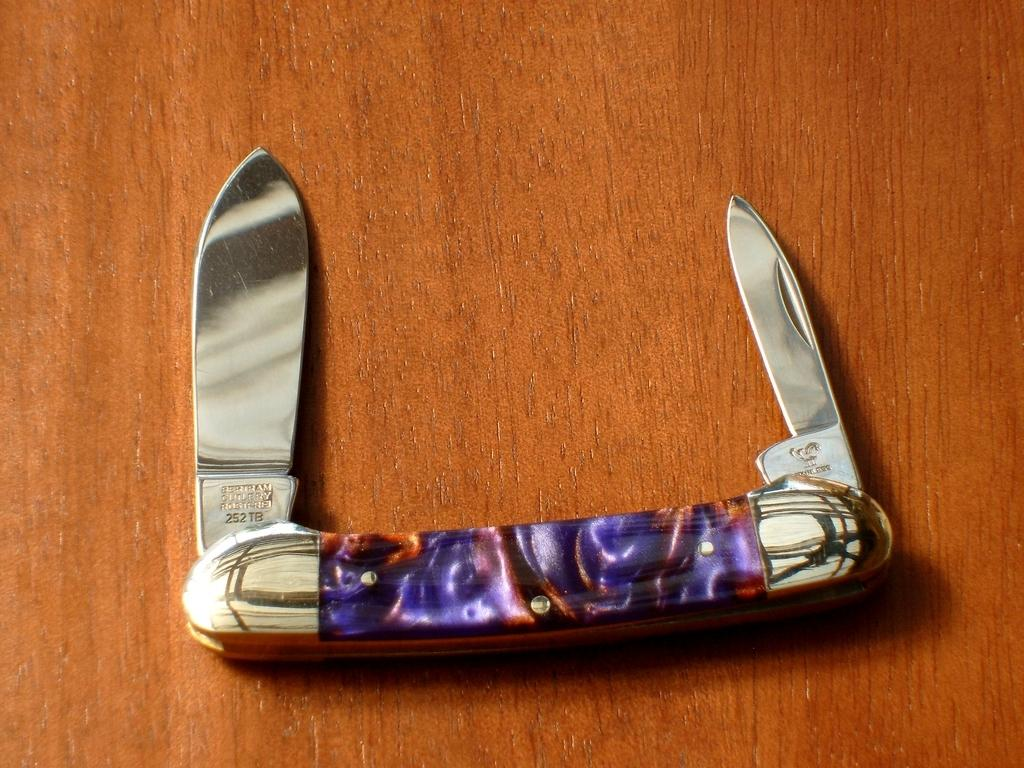What object can be seen in the image? There is a knife in the image. What is the knife placed on? The knife is on a brown-colored surface. What type of banana is being sliced with the knife in the image? There is no banana present in the image; only a knife on a brown-colored surface is visible. 